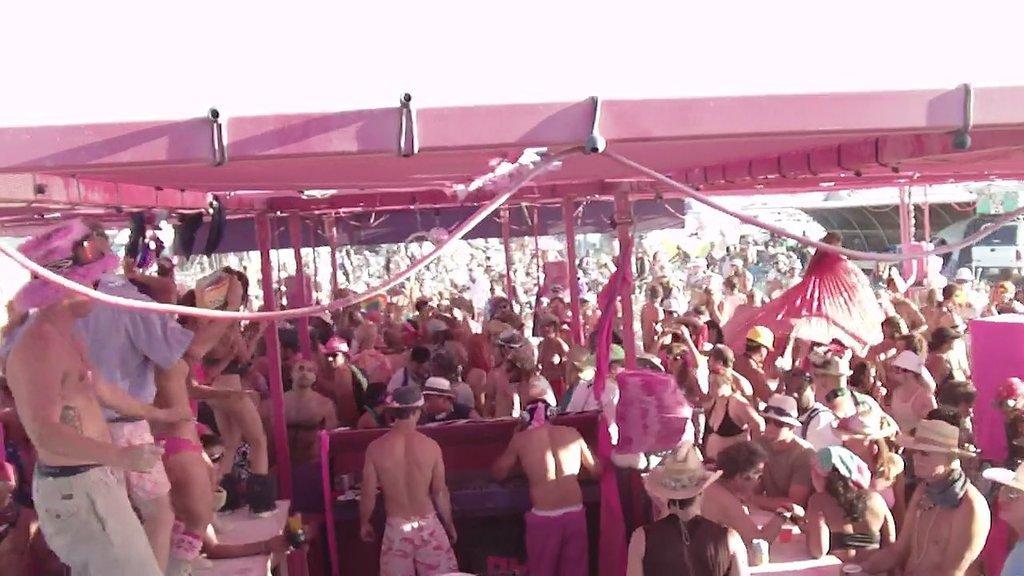Please provide a concise description of this image. In the image to the bottom there are many people with pink dress is standing and also there are poles with pink clothes. Above them there is a tent which is in pink color. To the top of the image there is a sky. 